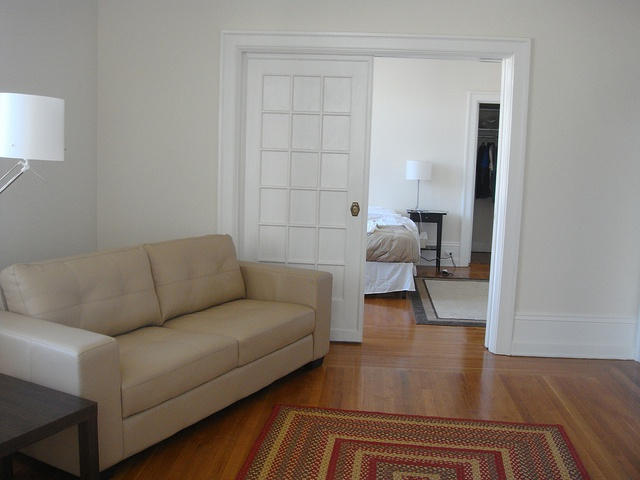Describe the objects in this image and their specific colors. I can see couch in gray and darkgray tones and bed in gray, darkgray, and lavender tones in this image. 